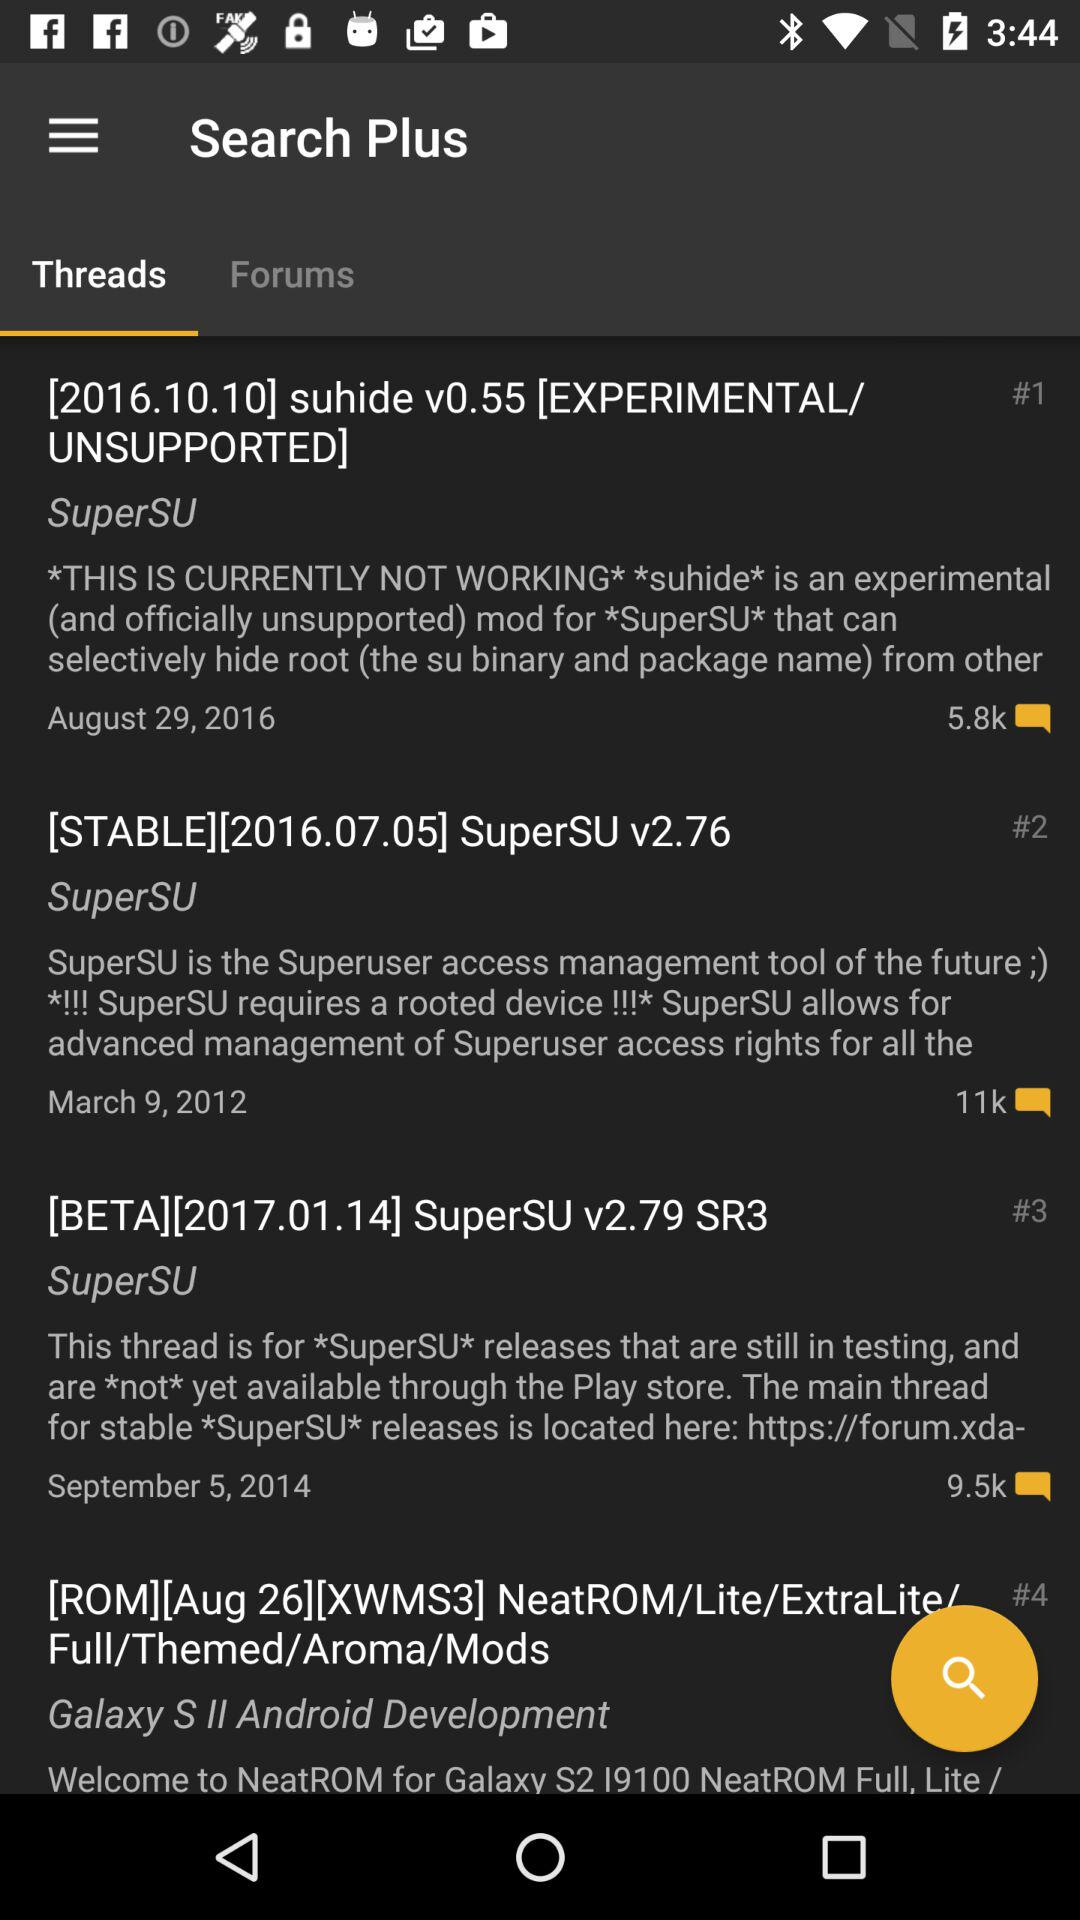How many threads are there in total?
Answer the question using a single word or phrase. 4 